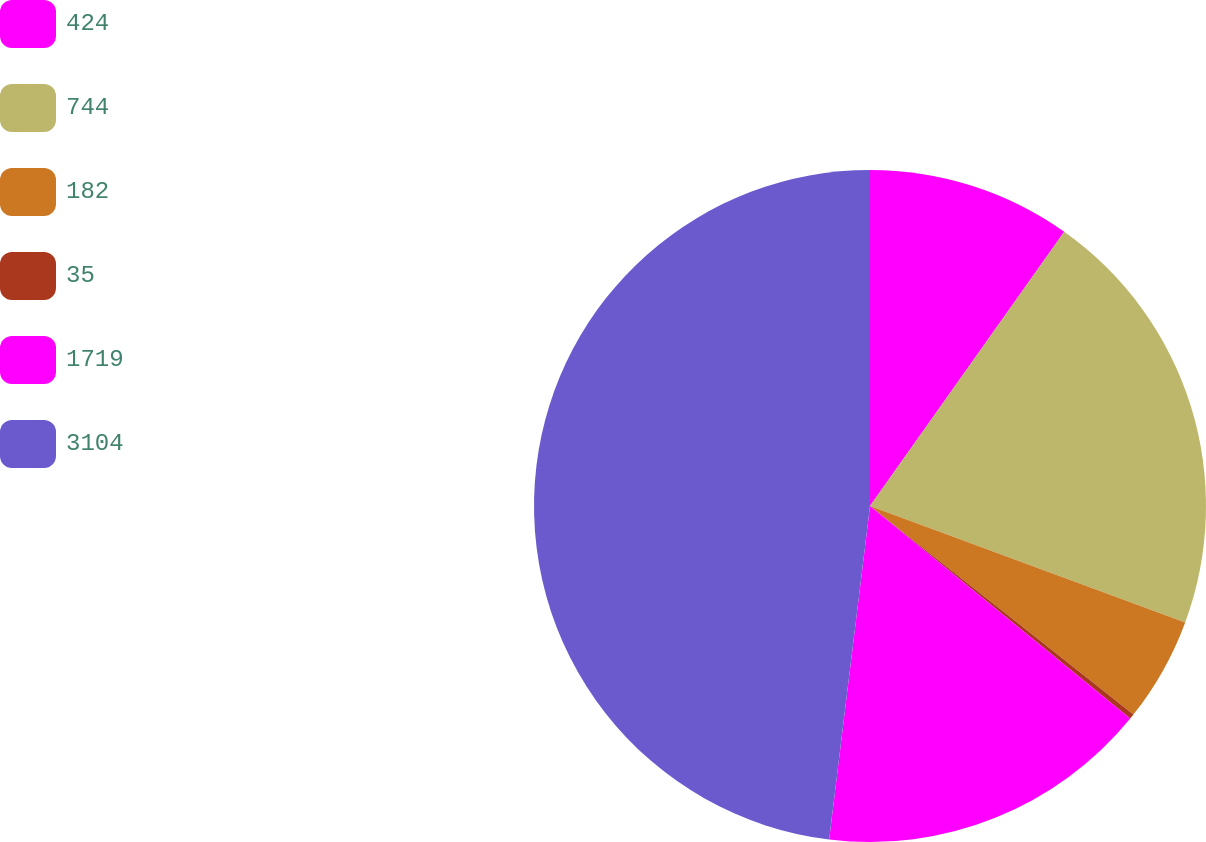Convert chart. <chart><loc_0><loc_0><loc_500><loc_500><pie_chart><fcel>424<fcel>744<fcel>182<fcel>35<fcel>1719<fcel>3104<nl><fcel>9.81%<fcel>20.82%<fcel>5.03%<fcel>0.24%<fcel>16.04%<fcel>48.06%<nl></chart> 